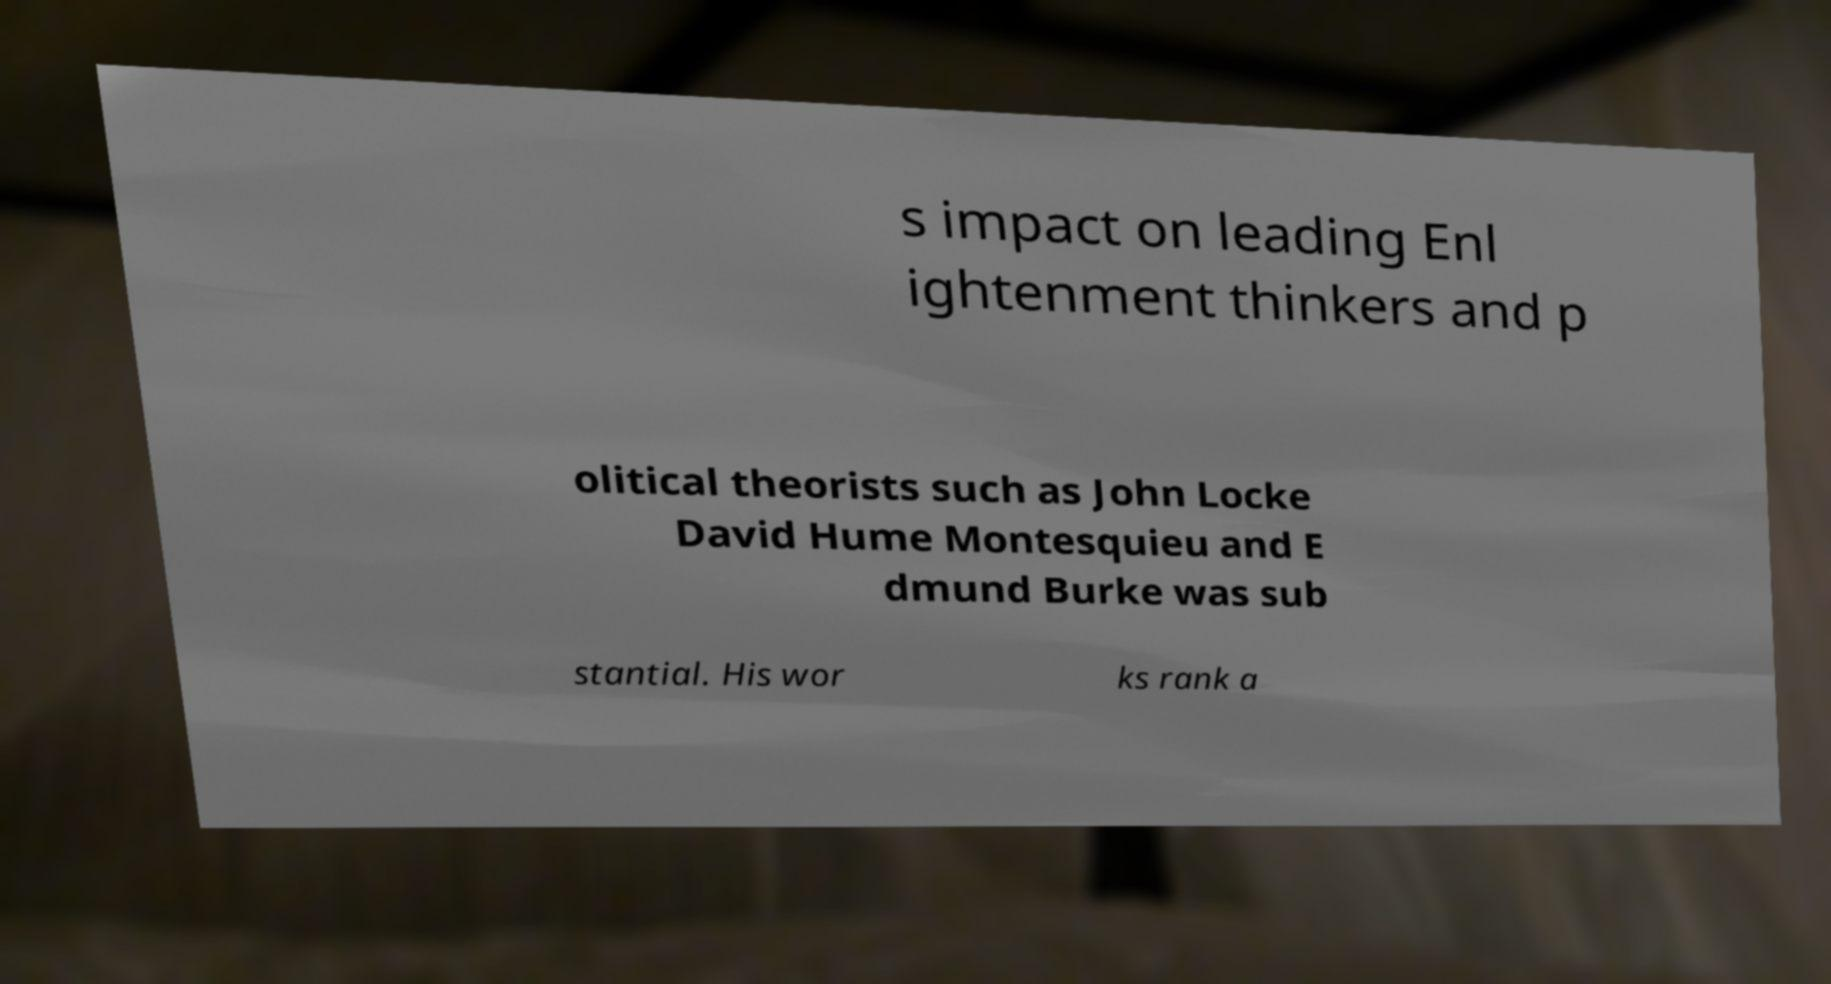For documentation purposes, I need the text within this image transcribed. Could you provide that? s impact on leading Enl ightenment thinkers and p olitical theorists such as John Locke David Hume Montesquieu and E dmund Burke was sub stantial. His wor ks rank a 